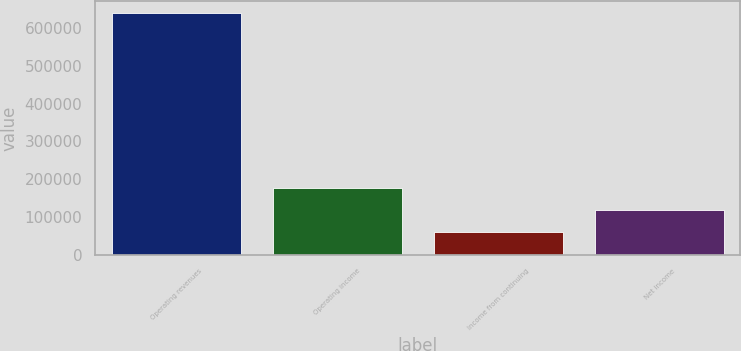Convert chart. <chart><loc_0><loc_0><loc_500><loc_500><bar_chart><fcel>Operating revenues<fcel>Operating income<fcel>Income from continuing<fcel>Net income<nl><fcel>639779<fcel>177083<fcel>60918<fcel>118804<nl></chart> 